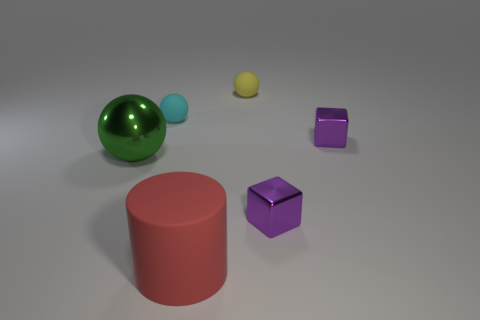Subtract all matte spheres. How many spheres are left? 1 Add 1 small cyan things. How many objects exist? 7 Subtract all cyan balls. How many balls are left? 2 Subtract all yellow cubes. How many green spheres are left? 1 Subtract all purple metallic cubes. Subtract all purple shiny blocks. How many objects are left? 2 Add 5 large matte cylinders. How many large matte cylinders are left? 6 Add 1 red objects. How many red objects exist? 2 Subtract 0 brown balls. How many objects are left? 6 Subtract all cylinders. How many objects are left? 5 Subtract 3 spheres. How many spheres are left? 0 